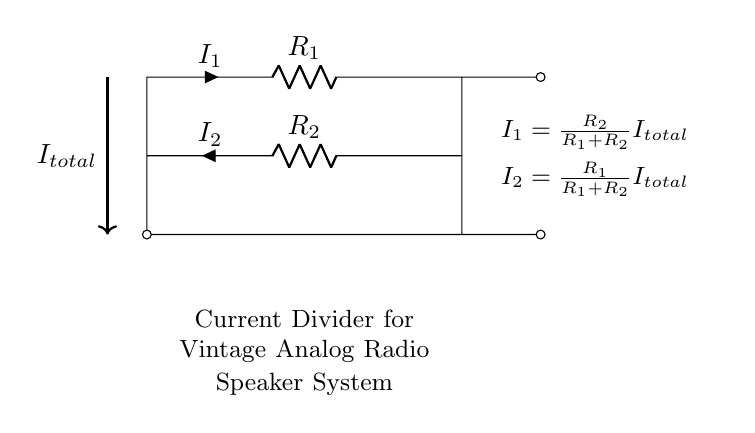What type of circuit is presented? This is a current divider circuit. Current dividers split the input current into smaller parts based on the resistance values.
Answer: Current divider What are the two resistors in the circuit? The resistors in the circuit are labeled as R1 and R2. They are the only resistive components depicted that contribute to the division of current.
Answer: R1 and R2 What is the total current entering the circuit? The total current entering the circuit is denoted as I total. It flows from the source through the resistors, dividing into I1 and I2.
Answer: I total How does the current I1 relate to the resistors? The formula for I1 is I1 equals R2 divided by the sum of R1 and R2 times I total. This shows how I1 depends on the resistances in the circuit.
Answer: I1 = R2/(R1 + R2) I total What happens to current I2 as R1 increases? As R1 increases, the formula for I2 shows that the fraction decreases because it is proportional to R1 over the sum of R1 and R2, resulting in less current through R2.
Answer: I2 decreases What does the node between R1 and R2 indicate? The node between R1 and R2 represents the division point where the total current splits into I1 and I2 based on their respective resistances.
Answer: Division point What is the total current flowing through R1 and R2? The total current flowing through both R1 and R2 is equal to I total, as they are in parallel and share the input current.
Answer: I total 